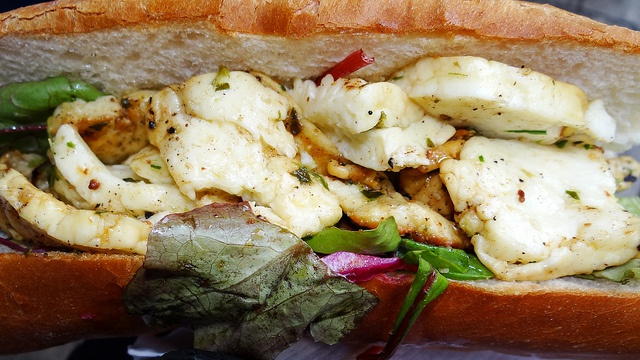Describe the objects in this image and their specific colors. I can see a sandwich in ivory, black, tan, maroon, and beige tones in this image. 